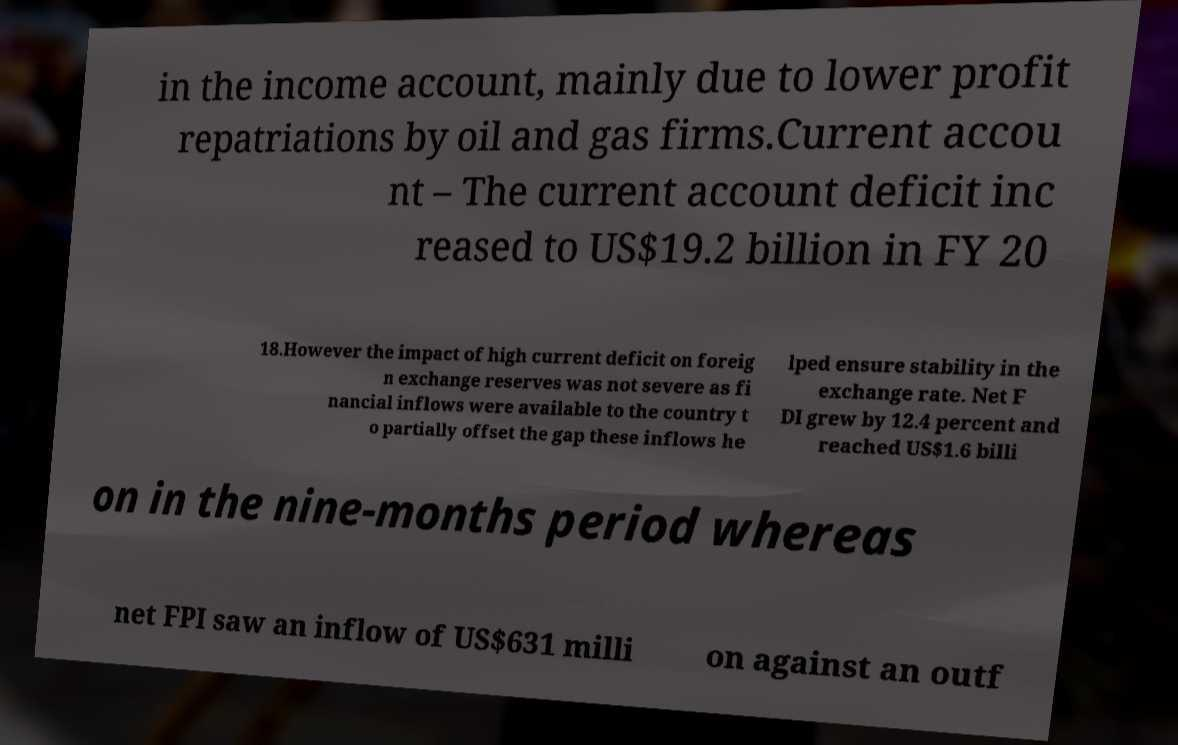There's text embedded in this image that I need extracted. Can you transcribe it verbatim? in the income account, mainly due to lower profit repatriations by oil and gas firms.Current accou nt – The current account deficit inc reased to US$19.2 billion in FY 20 18.However the impact of high current deficit on foreig n exchange reserves was not severe as fi nancial inflows were available to the country t o partially offset the gap these inflows he lped ensure stability in the exchange rate. Net F DI grew by 12.4 percent and reached US$1.6 billi on in the nine-months period whereas net FPI saw an inflow of US$631 milli on against an outf 